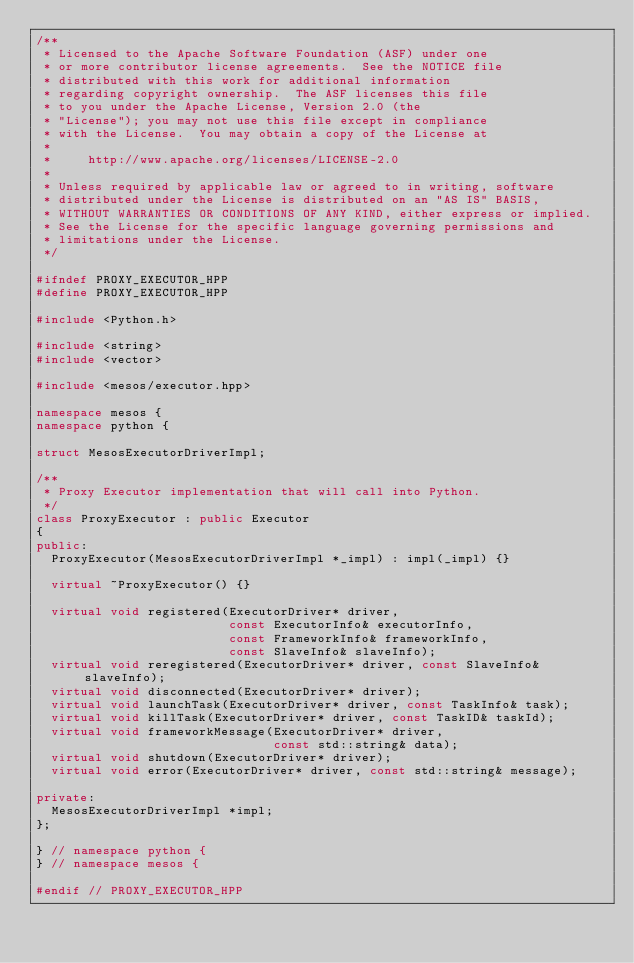Convert code to text. <code><loc_0><loc_0><loc_500><loc_500><_C++_>/**
 * Licensed to the Apache Software Foundation (ASF) under one
 * or more contributor license agreements.  See the NOTICE file
 * distributed with this work for additional information
 * regarding copyright ownership.  The ASF licenses this file
 * to you under the Apache License, Version 2.0 (the
 * "License"); you may not use this file except in compliance
 * with the License.  You may obtain a copy of the License at
 *
 *     http://www.apache.org/licenses/LICENSE-2.0
 *
 * Unless required by applicable law or agreed to in writing, software
 * distributed under the License is distributed on an "AS IS" BASIS,
 * WITHOUT WARRANTIES OR CONDITIONS OF ANY KIND, either express or implied.
 * See the License for the specific language governing permissions and
 * limitations under the License.
 */

#ifndef PROXY_EXECUTOR_HPP
#define PROXY_EXECUTOR_HPP

#include <Python.h>

#include <string>
#include <vector>

#include <mesos/executor.hpp>

namespace mesos {
namespace python {

struct MesosExecutorDriverImpl;

/**
 * Proxy Executor implementation that will call into Python.
 */
class ProxyExecutor : public Executor
{
public:
  ProxyExecutor(MesosExecutorDriverImpl *_impl) : impl(_impl) {}

  virtual ~ProxyExecutor() {}

  virtual void registered(ExecutorDriver* driver,
                          const ExecutorInfo& executorInfo,
                          const FrameworkInfo& frameworkInfo,
                          const SlaveInfo& slaveInfo);
  virtual void reregistered(ExecutorDriver* driver, const SlaveInfo& slaveInfo);
  virtual void disconnected(ExecutorDriver* driver);
  virtual void launchTask(ExecutorDriver* driver, const TaskInfo& task);
  virtual void killTask(ExecutorDriver* driver, const TaskID& taskId);
  virtual void frameworkMessage(ExecutorDriver* driver,
                                const std::string& data);
  virtual void shutdown(ExecutorDriver* driver);
  virtual void error(ExecutorDriver* driver, const std::string& message);

private:
  MesosExecutorDriverImpl *impl;
};

} // namespace python {
} // namespace mesos {

#endif // PROXY_EXECUTOR_HPP
</code> 